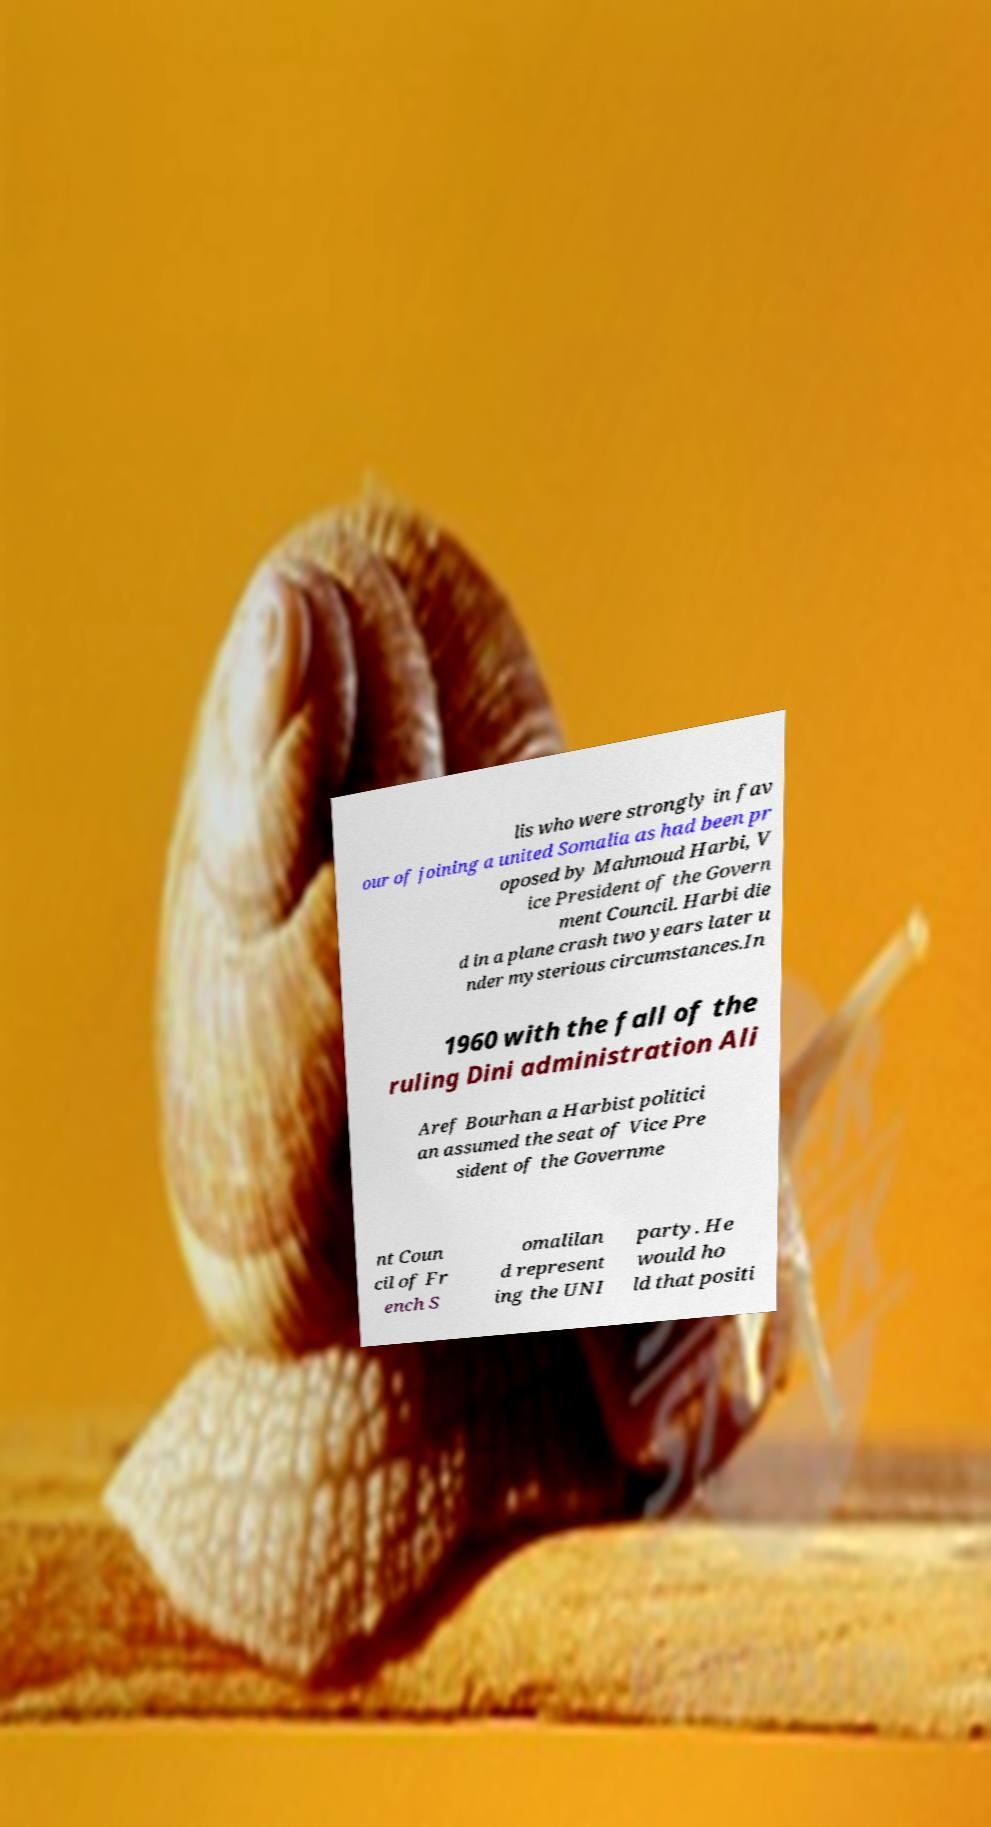I need the written content from this picture converted into text. Can you do that? lis who were strongly in fav our of joining a united Somalia as had been pr oposed by Mahmoud Harbi, V ice President of the Govern ment Council. Harbi die d in a plane crash two years later u nder mysterious circumstances.In 1960 with the fall of the ruling Dini administration Ali Aref Bourhan a Harbist politici an assumed the seat of Vice Pre sident of the Governme nt Coun cil of Fr ench S omalilan d represent ing the UNI party. He would ho ld that positi 